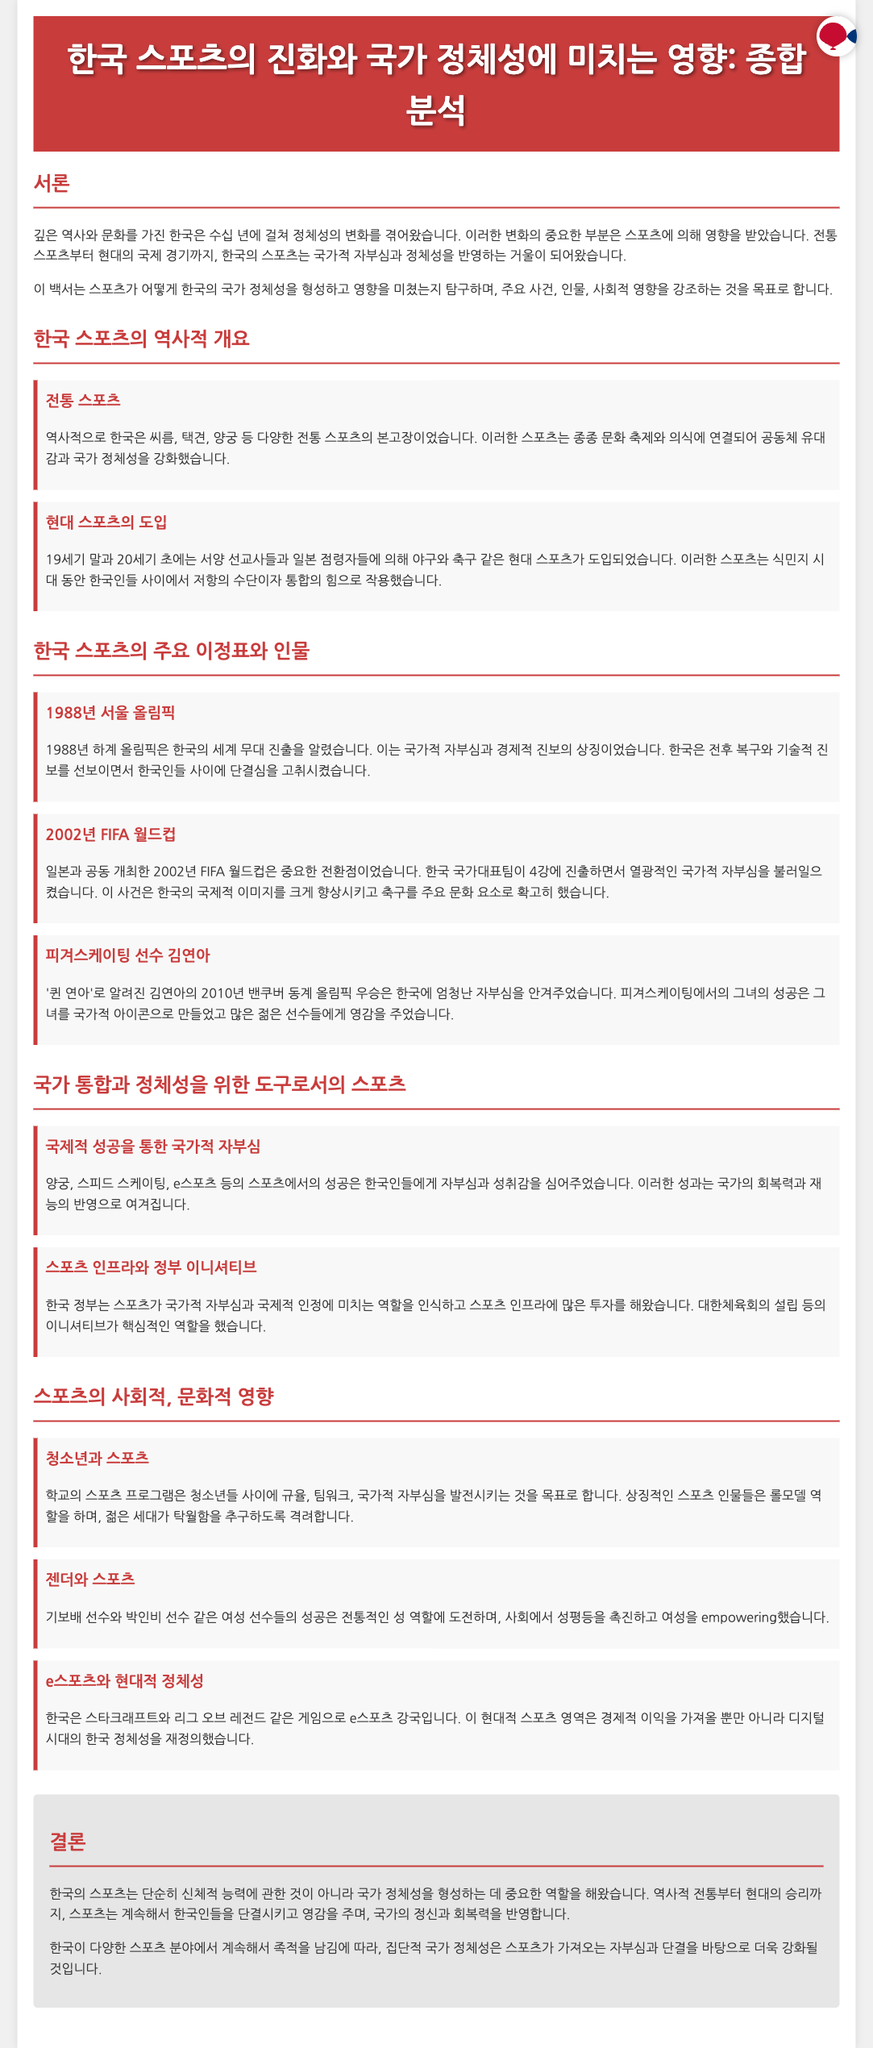What is the title of the whitepaper? The title of the whitepaper is presented at the top of the document.
Answer: 한국 스포츠의 진화와 국가 정체성에 미치는 영향: 종합 분석 In which year was the Seoul Olympics held? The document discusses the importance of the Seoul Olympics, specifically mentioning the year it took place.
Answer: 1988 What traditional sports are mentioned in the document? The document lists traditional sports that have historical significance in Korea.
Answer: 씨름, 택견, 양궁 Who is referred to as '퀸 연아'? The document mentions a particular figure recognized for her achievements in sports, leading to national pride.
Answer: 김연아 What impact did the 2002 FIFA World Cup have on Korea? The document highlights a significant event that bolstered national pride and international image.
Answer: 국가적 자부심 How does the government support sports in Korea? The document details initiatives undertaken by the government to enhance sports infrastructure and national pride.
Answer: 많은 투자 What role do sports programs play for youth? The document explains the purpose of school sports programs in developing particular qualities among young people.
Answer: 규율, 팀워크, 국가적 자부심 What is Korea's position in eSports? The document states Korea's prominence in a specific modern sports domain, emphasizing its cultural impact.
Answer: 강국 How does Kim Yuna's success influence youth? The document indicates that successful sports figures serve as role models for the younger generation.
Answer: 영감을 주었습니다 